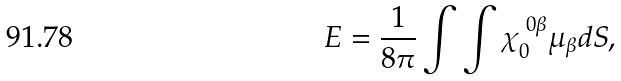<formula> <loc_0><loc_0><loc_500><loc_500>E = \frac { 1 } { 8 \pi } \int \int { \chi } _ { 0 } ^ { \ 0 \beta } \mu _ { \beta } d S ,</formula> 